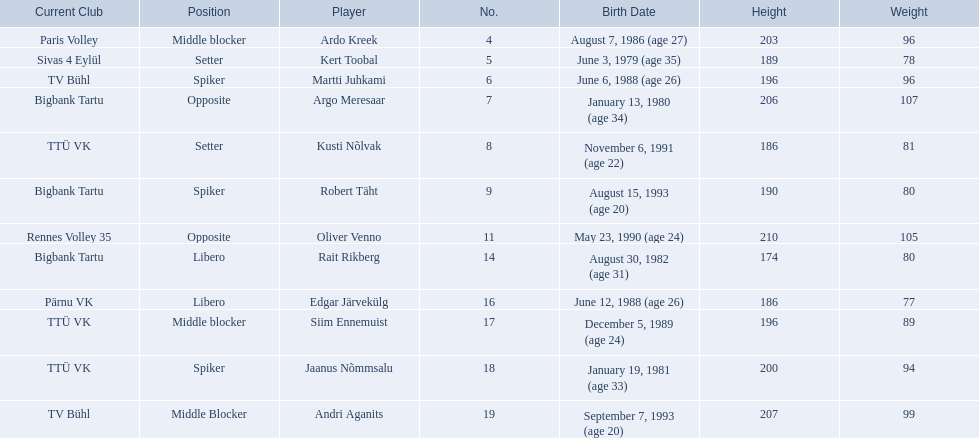What are the heights in cm of the men on the team? 203, 189, 196, 206, 186, 190, 210, 174, 186, 196, 200, 207. What is the tallest height of a team member? 210. Which player stands at 210? Oliver Venno. 